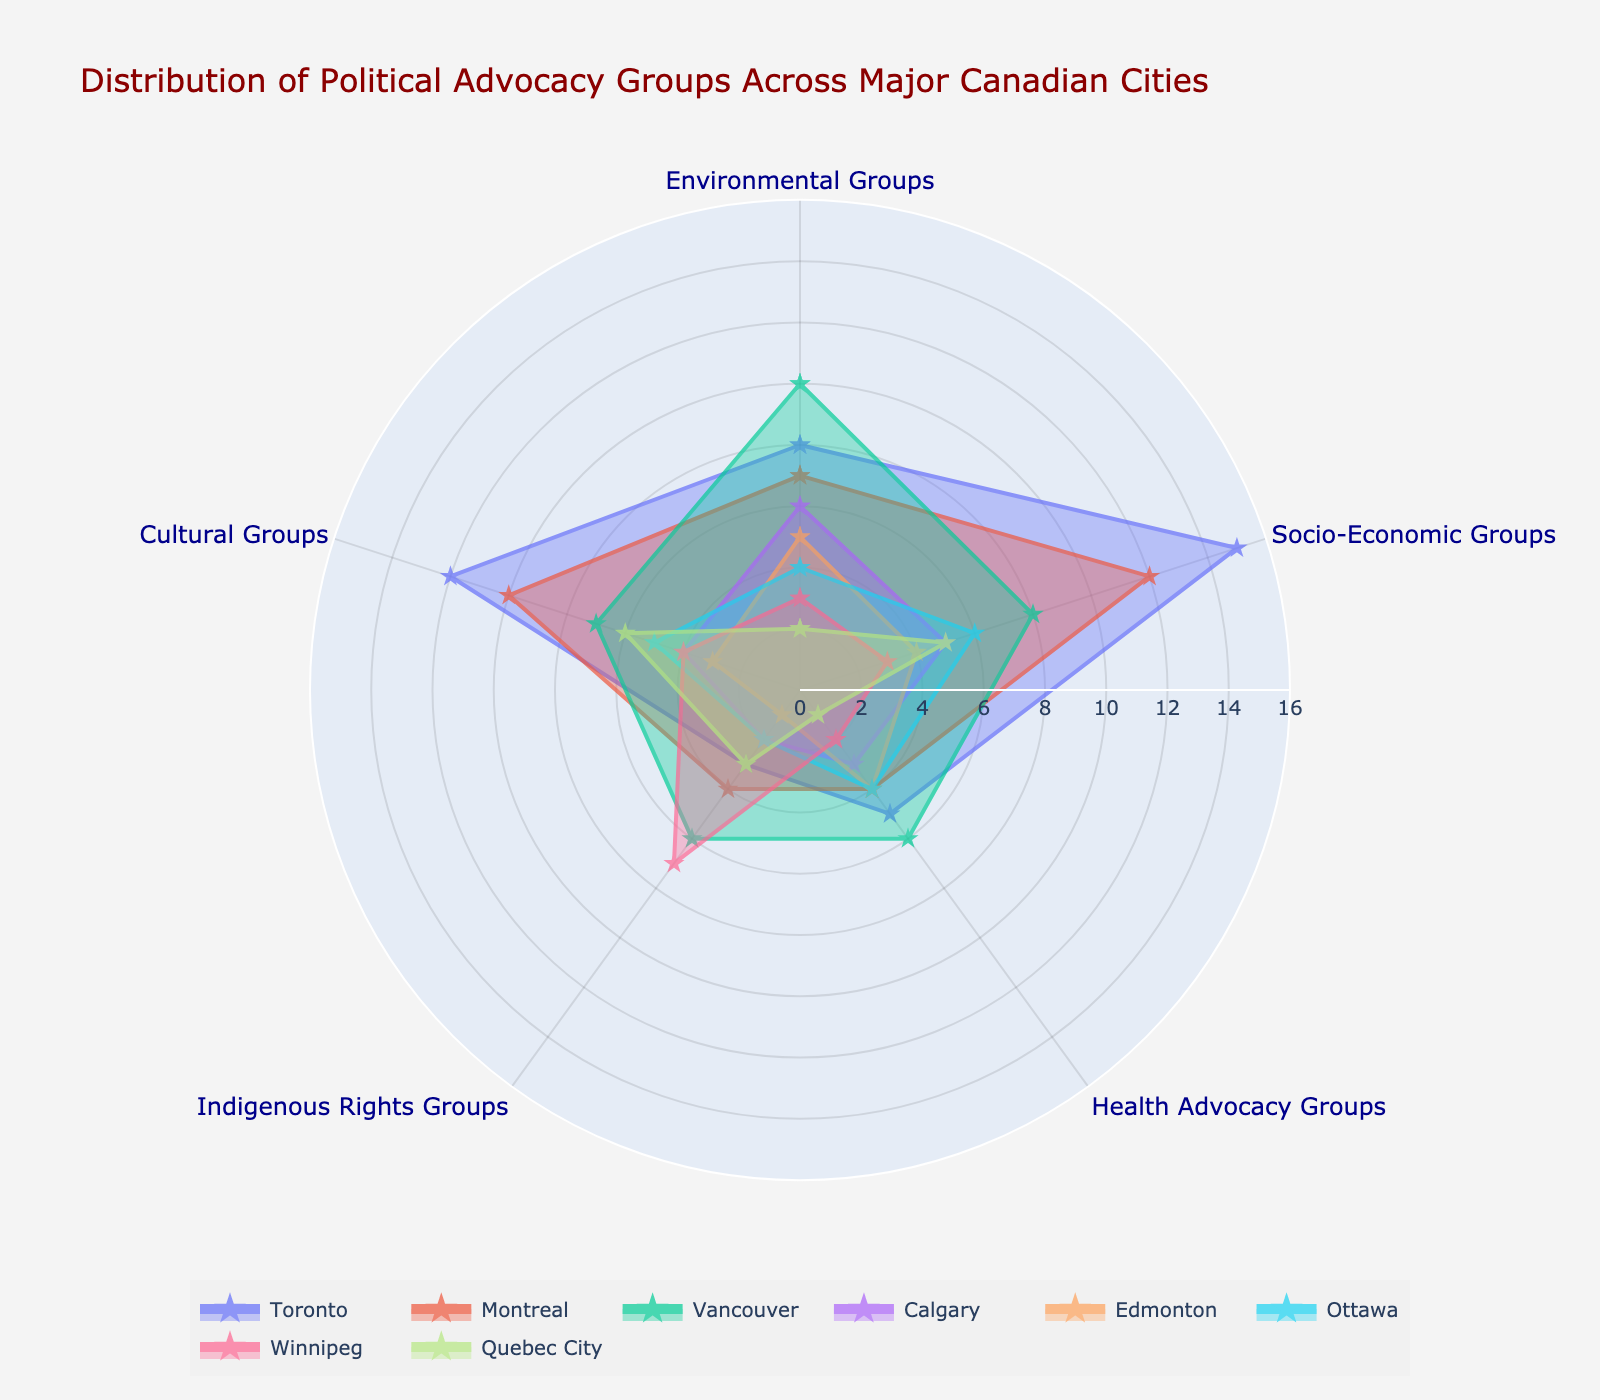How many Environmental Groups are there in Vancouver? According to the Polar Chart, Vancouver has a specific segment indicating the number of Environmental Groups. By looking at the chart, it is evident that this segment shows 10 Environmental Groups.
Answer: 10 Which city has the highest number of Cultural Groups? By examining the various segments for Cultural Groups across cities in the Polar Chart, Toronto has the highest number of Cultural Groups, which is indicated as 12.
Answer: Toronto What is the sum of Health Advocacy Groups in Calgary and Ottawa? To find the sum, look at the respective segments for Health Advocacy Groups in Calgary and Ottawa. Calgary has 3 and Ottawa has 4 Health Advocacy Groups. Summing them up, 3 + 4 = 7.
Answer: 7 Which cities have an equal number of Indigenous Rights Groups? By examining the segments for Indigenous Rights Groups across cities, Montreal and Quebec City both have 3 Indigenous Rights Groups, indicating they are equal.
Answer: Montreal and Quebec City Which group has the greatest representation in Toronto? In the Polar Chart, the largest segment for Toronto corresponds to Socio-Economic Groups, indicating a count of 15, which is the highest compared to other groups in the same city.
Answer: Socio-Economic Groups How many more Environmental Groups does Vancouver have compared to Edmonton? By looking at the Environmental Groups segment for both cities, Vancouver has 10 while Edmonton has 5. The difference is 10 - 5 = 5.
Answer: 5 In which city does the Indigenous Rights Group outnumber the Socio-Economic Groups? Winnipeg is the only city where the segment for Indigenous Rights Groups (7) is greater than that of Socio-Economic Groups (3) in the Polar Chart.
Answer: Winnipeg What is the average number of Socio-Economic Groups across all cities? Summing the Socio-Economic Groups from all cities: 15 (Toronto) + 12 (Montreal) + 8 (Vancouver) + 5 (Calgary) + 4 (Edmonton) + 6 (Ottawa) + 3 (Winnipeg) + 5 (Quebec City) = 58. The average is 58/8 = 7.25.
Answer: 7.25 Which city has the least number of Health Advocacy Groups? According to the Polar Chart, Quebec City has the lowest count for Health Advocacy Groups, which is indicated as 1.
Answer: Quebec City 